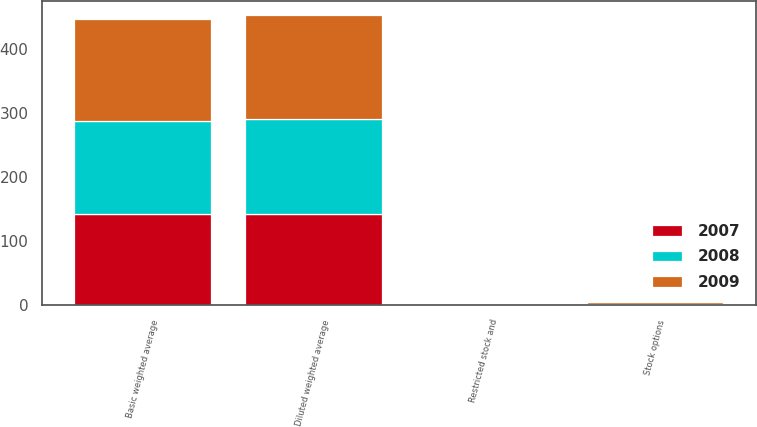Convert chart. <chart><loc_0><loc_0><loc_500><loc_500><stacked_bar_chart><ecel><fcel>Basic weighted average<fcel>Stock options<fcel>Restricted stock and<fcel>Diluted weighted average<nl><fcel>2007<fcel>141.6<fcel>0.7<fcel>0.2<fcel>142.5<nl><fcel>2008<fcel>146.5<fcel>1.6<fcel>0.1<fcel>148.2<nl><fcel>2009<fcel>158.7<fcel>2.4<fcel>0.1<fcel>161.2<nl></chart> 